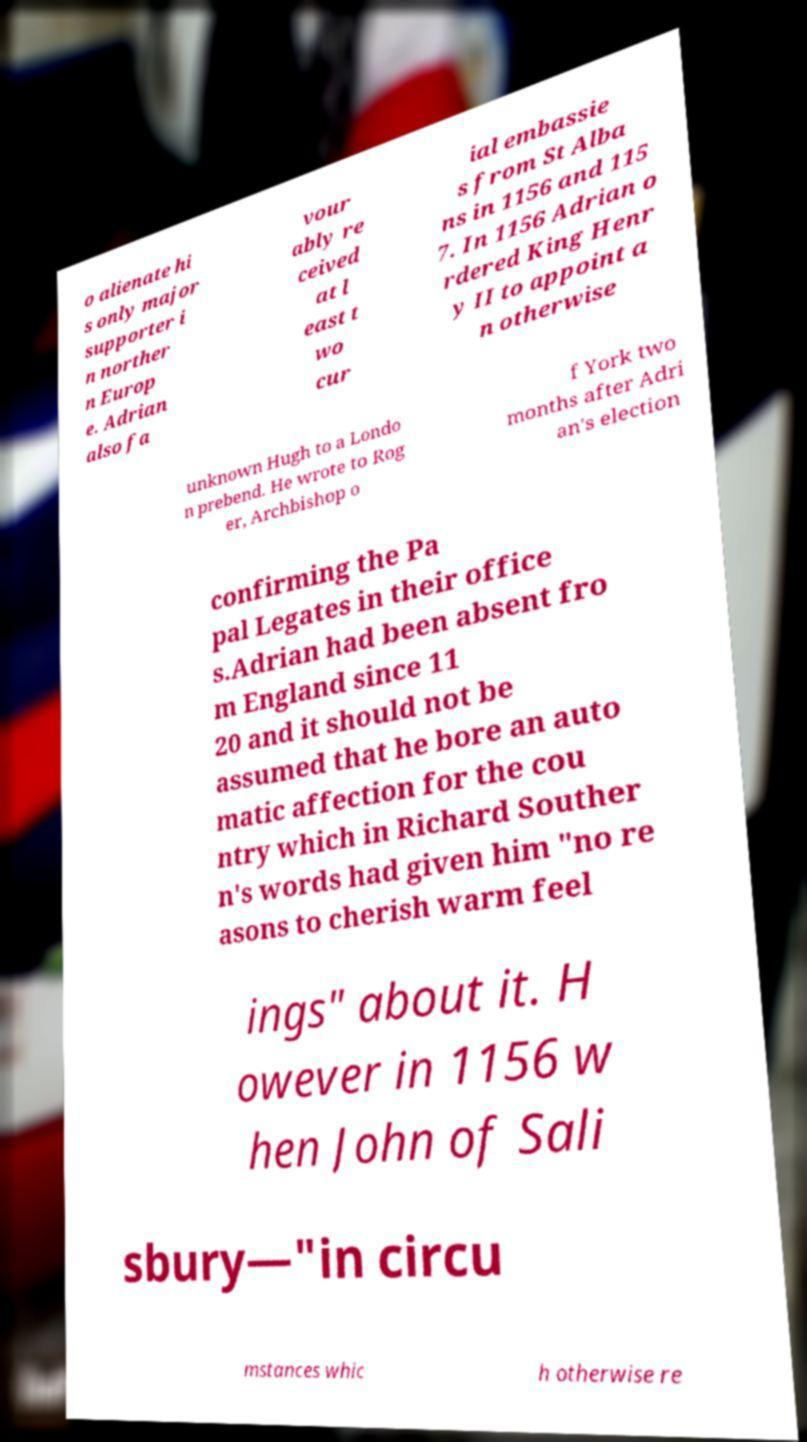Could you assist in decoding the text presented in this image and type it out clearly? o alienate hi s only major supporter i n norther n Europ e. Adrian also fa vour ably re ceived at l east t wo cur ial embassie s from St Alba ns in 1156 and 115 7. In 1156 Adrian o rdered King Henr y II to appoint a n otherwise unknown Hugh to a Londo n prebend. He wrote to Rog er, Archbishop o f York two months after Adri an's election confirming the Pa pal Legates in their office s.Adrian had been absent fro m England since 11 20 and it should not be assumed that he bore an auto matic affection for the cou ntry which in Richard Souther n's words had given him "no re asons to cherish warm feel ings" about it. H owever in 1156 w hen John of Sali sbury—"in circu mstances whic h otherwise re 